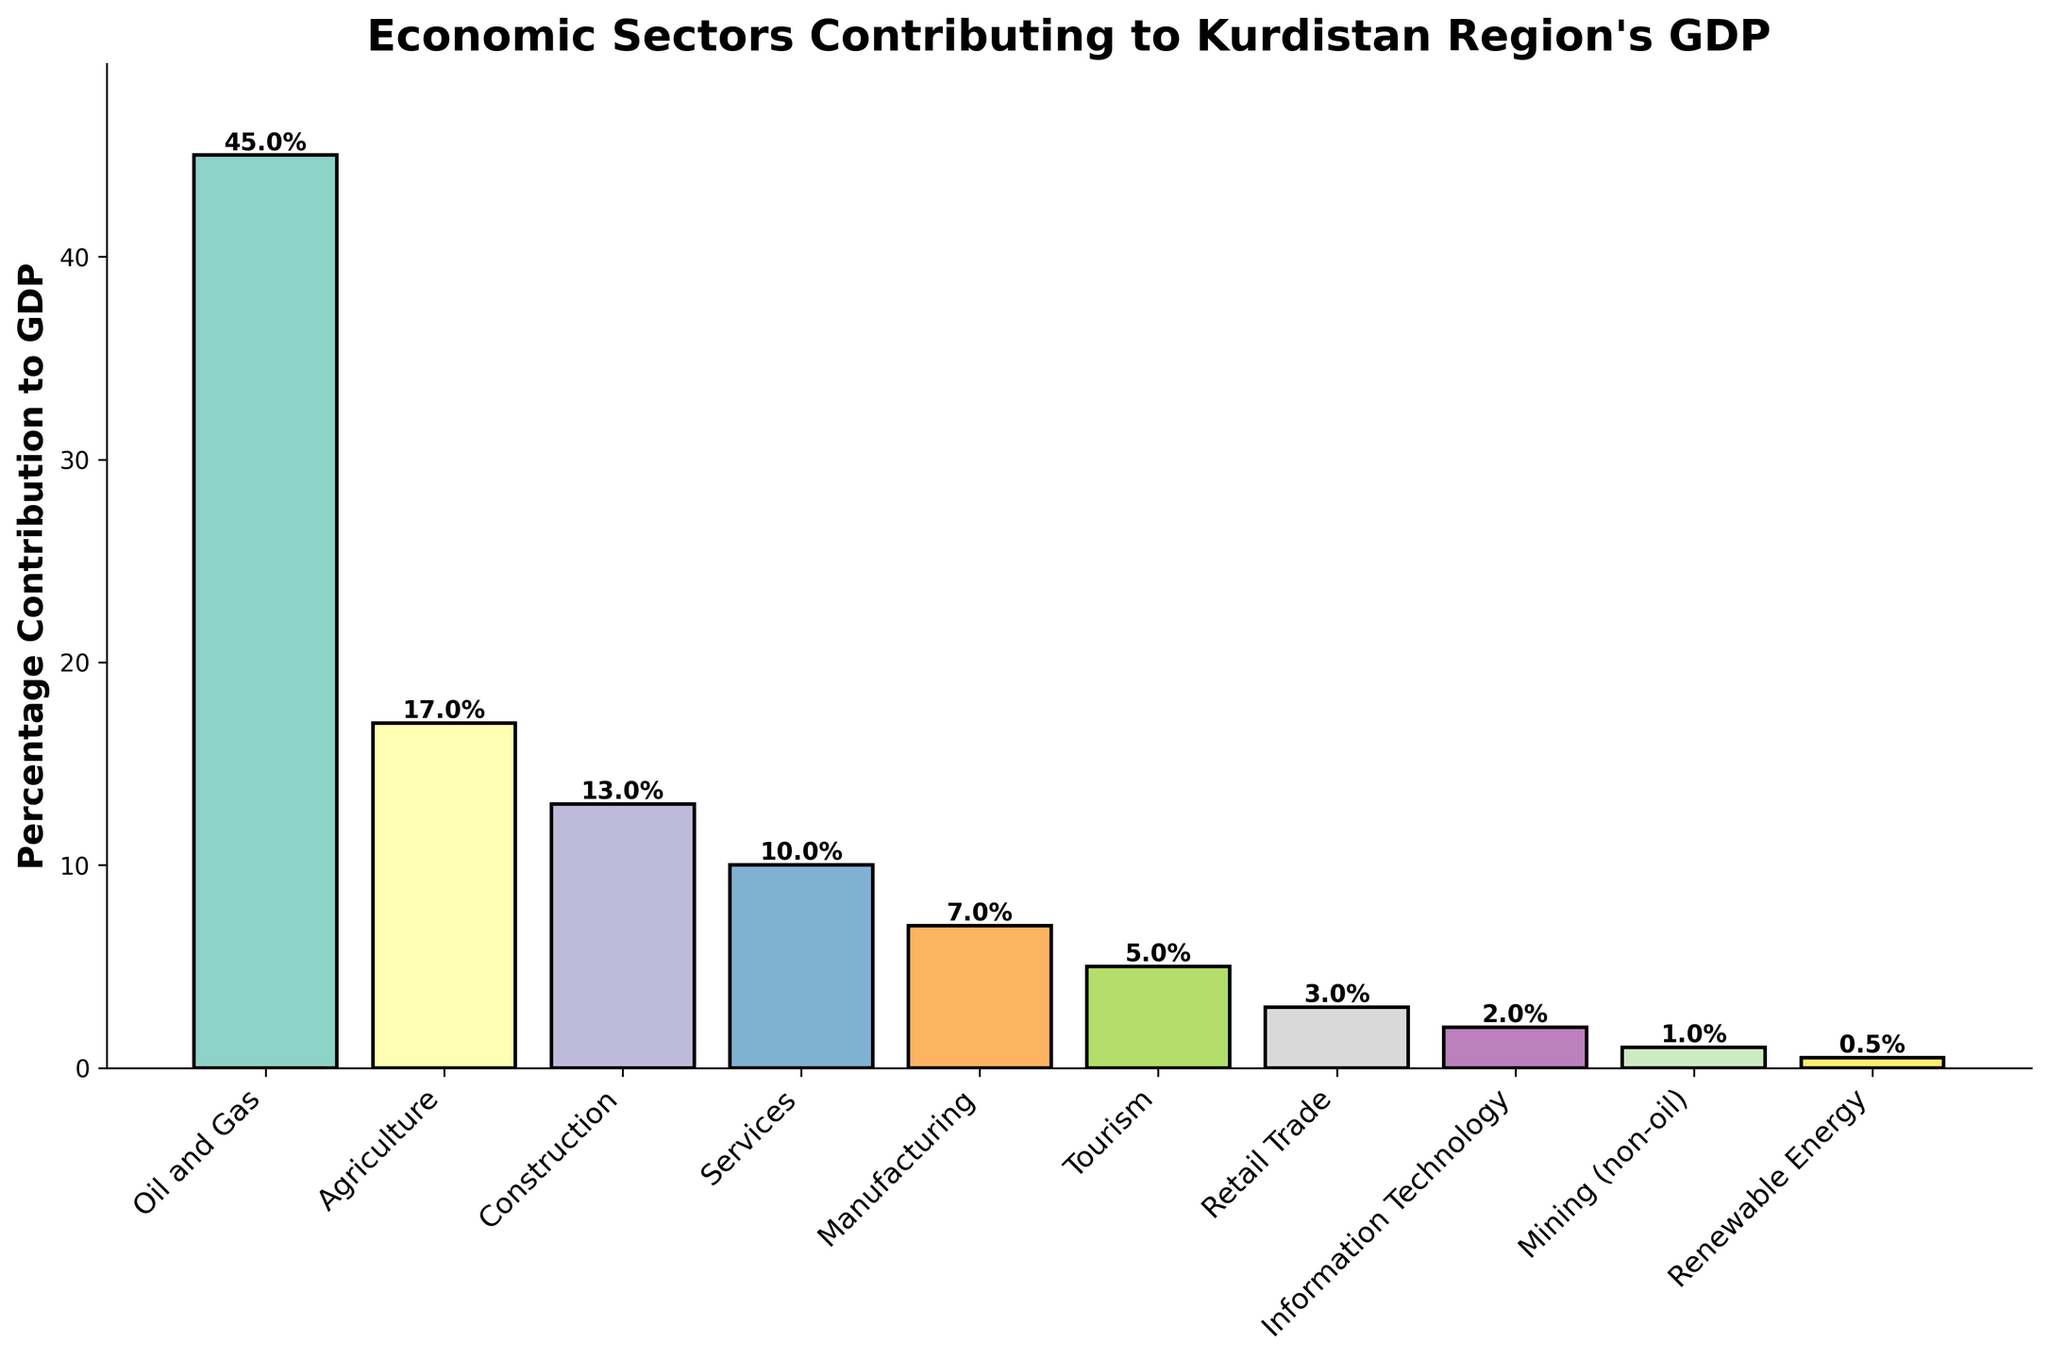Which sector contributes the most to Kurdistan Region's GDP? The tallest bar in the figure represents the sector that contributes the most, which is labeled "Oil and Gas" with a percentage of 45%.
Answer: Oil and Gas Which sector has the smallest contribution to Kurdistan Region's GDP? The shortest bar in the figure represents the sector with the smallest contribution, which is labeled "Renewable Energy" with a percentage of 0.5%.
Answer: Renewable Energy What is the total contribution of Agriculture and Construction sectors to Kurdistan Region's GDP? The percentages for Agriculture and Construction are 17% and 13% respectively. Adding these together: 17 + 13 = 30%.
Answer: 30% How much more does the Oil and Gas sector contribute compared to the Manufacturing sector? The percentage for Oil and Gas is 45% and for Manufacturing, it is 7%. Subtracting these: 45 - 7 = 38%.
Answer: 38% Which sector contributes more to the GDP: Services or Tourism, and by how much? The percentage for Services is 10% and for Tourism, it is 5%. Subtracting these: 10 - 5 = 5%.
Answer: Services by 5% What is the sum of contributions from Agriculture, Construction, and Manufacturing sectors? The percentages for Agriculture, Construction, and Manufacturing are 17%, 13%, and 7% respectively. Adding these together: 17 + 13 + 7 = 37%.
Answer: 37% List the sectors that contribute less than 10% to Kurdistan Region's GDP. The figure shows the sectors with percentages below 10%: Manufacturing (7%), Tourism (5%), Retail Trade (3%), Information Technology (2%), Mining (non-oil) (1%), and Renewable Energy (0.5%).
Answer: Manufacturing, Tourism, Retail Trade, Information Technology, Mining (non-oil), Renewable Energy Which sector's bar is the third tallest in the visual representation? Observing the heights of the bars, the third tallest bar represents the Construction sector, which contributes 13%.
Answer: Construction What is the combined percentage contribution of sectors related to energy (Oil and Gas & Renewable Energy)? Oil and Gas contributes 45% and Renewable Energy contributes 0.5%. Adding these together: 45 + 0.5 = 45.5%.
Answer: 45.5% How does the contribution of Retail Trade compare to Information Technology? The percentage for Retail Trade is 3%, whereas for Information Technology, it is 2%. Retail Trade contributes 1% more than Information Technology.
Answer: Retail Trade by 1% 